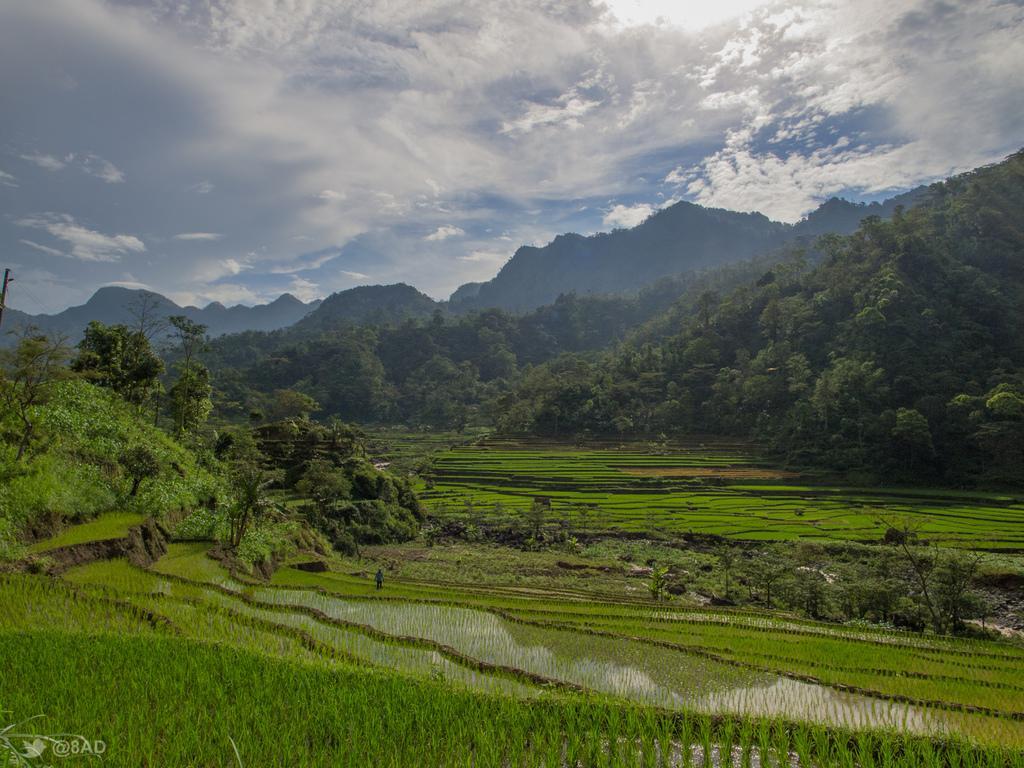Please provide a concise description of this image. In this image we can see grass and water on the surface, in the background of the image there are trees and mountains, at the top of the image there are clouds in the sky. 